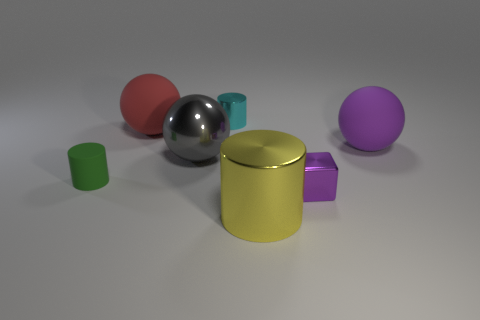How many cylinders are either large purple objects or large yellow metal objects?
Give a very brief answer. 1. What color is the large matte ball behind the matte sphere on the right side of the large metallic thing that is left of the large yellow metal thing?
Ensure brevity in your answer.  Red. How many other things are there of the same size as the gray sphere?
Provide a short and direct response. 3. Are there any other things that have the same shape as the big red rubber object?
Your answer should be very brief. Yes. What is the color of the small metallic object that is the same shape as the large yellow metallic thing?
Offer a terse response. Cyan. There is a tiny cylinder that is the same material as the tiny block; what is its color?
Provide a succinct answer. Cyan. Are there the same number of tiny metallic cubes in front of the big yellow cylinder and large purple objects?
Keep it short and to the point. No. There is a cylinder behind the green thing; is it the same size as the large red rubber object?
Your answer should be very brief. No. There is a rubber object that is the same size as the purple block; what color is it?
Provide a succinct answer. Green. Is there a block left of the metallic cylinder that is in front of the small thing in front of the tiny green rubber object?
Your answer should be compact. No. 